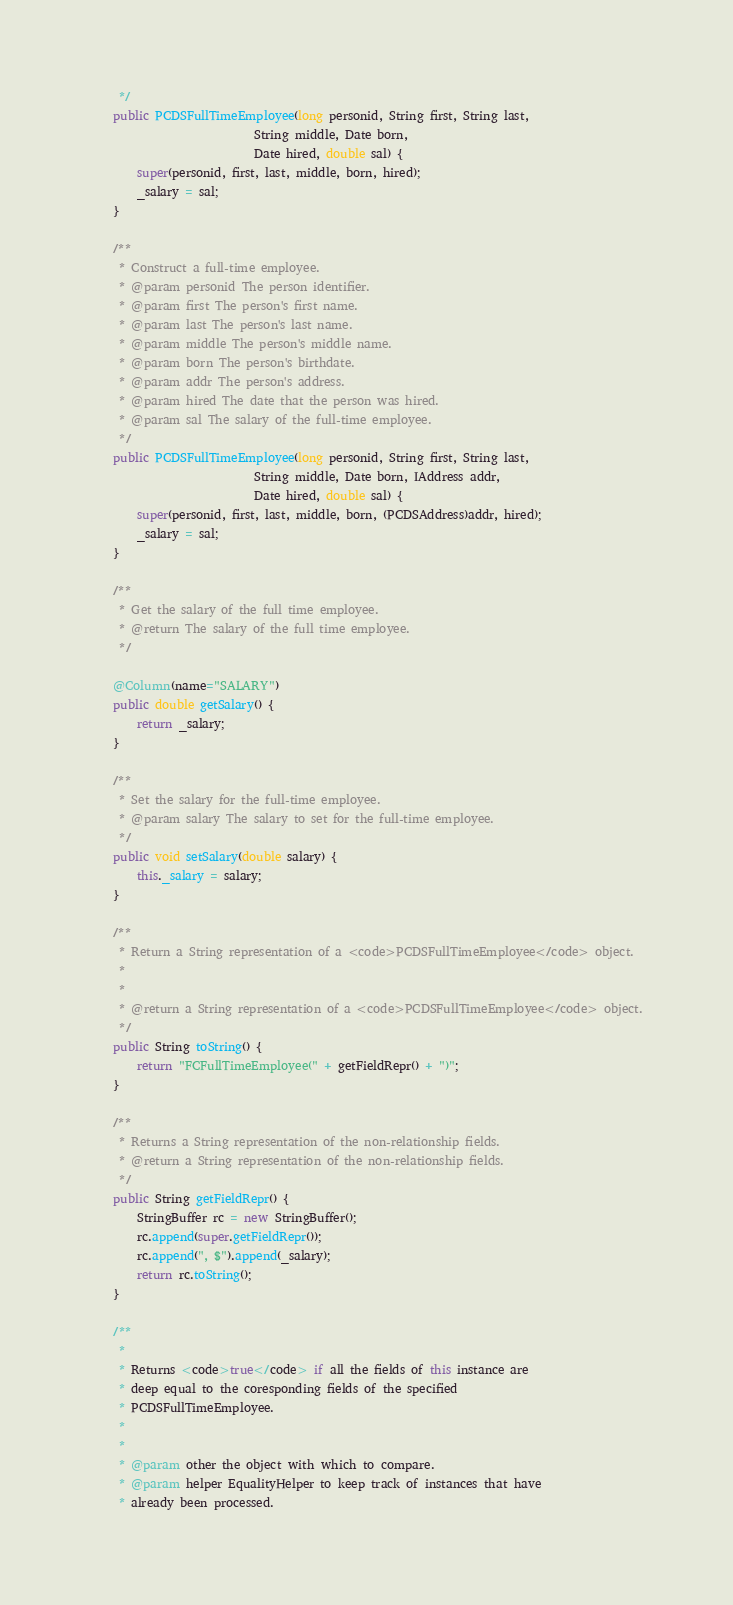<code> <loc_0><loc_0><loc_500><loc_500><_Java_>     */
    public PCDSFullTimeEmployee(long personid, String first, String last,
                            String middle, Date born,
                            Date hired, double sal) {
        super(personid, first, last, middle, born, hired);
        _salary = sal;
    }

    /**
     * Construct a full-time employee.
     * @param personid The person identifier.
     * @param first The person's first name.
     * @param last The person's last name.
     * @param middle The person's middle name.
     * @param born The person's birthdate.
     * @param addr The person's address.
     * @param hired The date that the person was hired.
     * @param sal The salary of the full-time employee.
     */
    public PCDSFullTimeEmployee(long personid, String first, String last,
                            String middle, Date born, IAddress addr, 
                            Date hired, double sal) {
        super(personid, first, last, middle, born, (PCDSAddress)addr, hired);
        _salary = sal;
    }

    /**
     * Get the salary of the full time employee.
     * @return The salary of the full time employee.
     */

    @Column(name="SALARY")
    public double getSalary() {
        return _salary;
    }
    
    /**
     * Set the salary for the full-time employee.
     * @param salary The salary to set for the full-time employee.
     */
    public void setSalary(double salary) {
        this._salary = salary;
    }
    
    /**
     * Return a String representation of a <code>PCDSFullTimeEmployee</code> object.
     * 
     * 
     * @return a String representation of a <code>PCDSFullTimeEmployee</code> object.
     */
    public String toString() {
        return "FCFullTimeEmployee(" + getFieldRepr() + ")";
    }

    /**
     * Returns a String representation of the non-relationship fields.
     * @return a String representation of the non-relationship fields.
     */
    public String getFieldRepr() {
        StringBuffer rc = new StringBuffer();
        rc.append(super.getFieldRepr());
        rc.append(", $").append(_salary);
        return rc.toString();
    }

    /**
     * 
     * Returns <code>true</code> if all the fields of this instance are
     * deep equal to the coresponding fields of the specified
     * PCDSFullTimeEmployee. 
     * 
     * 
     * @param other the object with which to compare.
     * @param helper EqualityHelper to keep track of instances that have
     * already been processed.</code> 